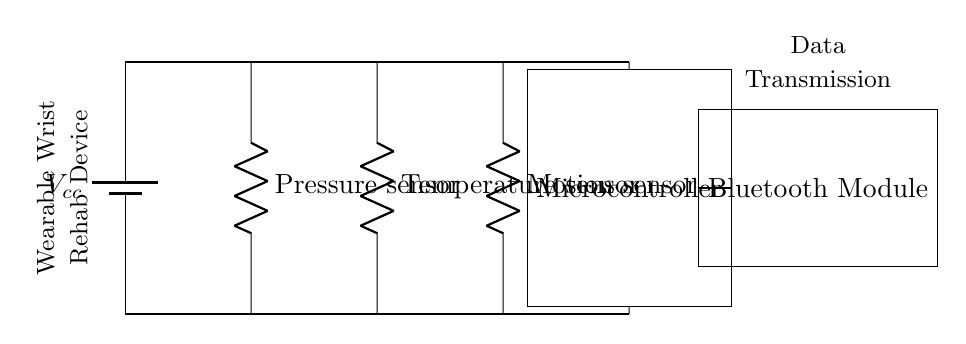What are the sensors included in this circuit? The circuit includes a pressure sensor, a temperature sensor, and a motion sensor. Each sensor is connected in parallel between the main voltage source and the microcontroller.
Answer: pressure sensor, temperature sensor, motion sensor How many branches are in the circuit? The circuit has three branches, each dedicated to one of the sensors, in addition to the main power and ground lines. This setup allows each sensor to operate independently within the parallel configuration.
Answer: three What is the power source labeled as? The power source is labeled as Vcc, which is a common notation for the positive voltage supply in circuits. It provides the necessary voltage for the sensors to operate.
Answer: Vcc What type of circuit is this? The circuit is a parallel circuit, as indicated by the configuration where multiple components (sensors) are connected across the same voltage source and share the same voltage.
Answer: parallel What is the role of the microcontroller in this circuit? The microcontroller processes data from the sensors and manages the communication to external devices, such as the Bluetooth module for data transmission.
Answer: processing data Which module is used for data transmission? The Bluetooth module is specified in the circuit, which allows for wireless transmission of data from the wearable device to other devices for monitoring or analysis.
Answer: Bluetooth module 